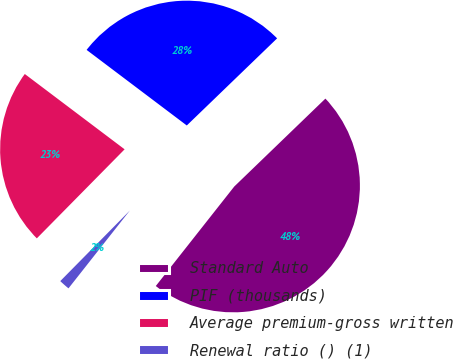Convert chart. <chart><loc_0><loc_0><loc_500><loc_500><pie_chart><fcel>Standard Auto<fcel>PIF (thousands)<fcel>Average premium-gross written<fcel>Renewal ratio () (1)<nl><fcel>47.84%<fcel>27.5%<fcel>22.9%<fcel>1.76%<nl></chart> 